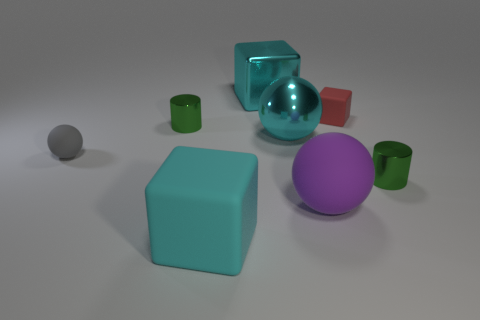There is a large shiny thing that is the same color as the large metallic cube; what shape is it?
Provide a short and direct response. Sphere. What number of other spheres are the same color as the big rubber sphere?
Give a very brief answer. 0. What is the shape of the other matte object that is the same size as the red thing?
Make the answer very short. Sphere. There is a big cyan rubber thing; are there any cubes in front of it?
Offer a very short reply. No. Do the cyan metal ball and the purple rubber thing have the same size?
Your response must be concise. Yes. What is the shape of the tiny matte object that is behind the tiny gray matte thing?
Ensure brevity in your answer.  Cube. Are there any purple matte things that have the same size as the cyan matte object?
Give a very brief answer. Yes. What material is the cube that is the same size as the gray matte sphere?
Your response must be concise. Rubber. There is a cyan shiny thing in front of the small red matte cube; what size is it?
Provide a short and direct response. Large. What size is the metal cube?
Provide a succinct answer. Large. 